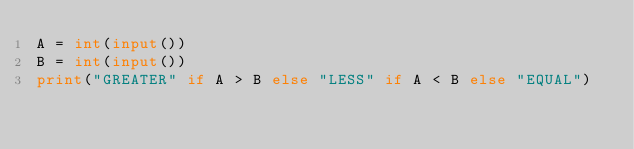<code> <loc_0><loc_0><loc_500><loc_500><_Python_>A = int(input())
B = int(input())
print("GREATER" if A > B else "LESS" if A < B else "EQUAL")</code> 